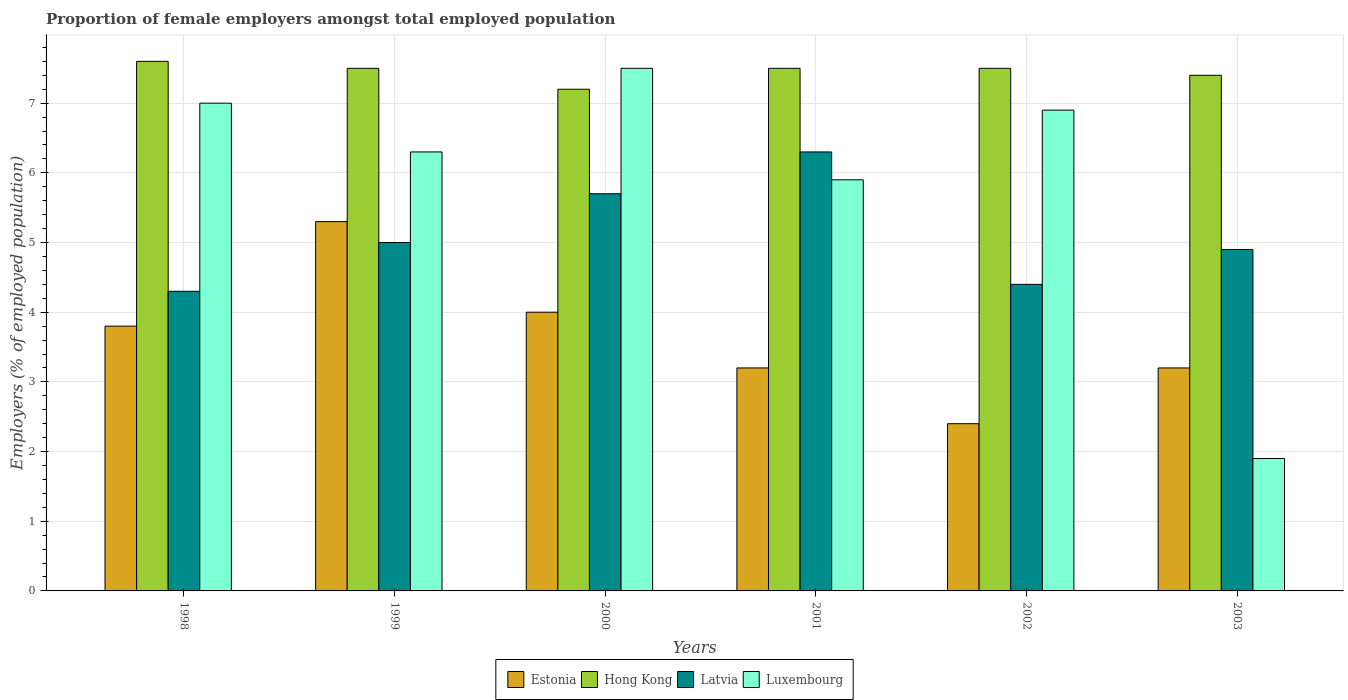How many different coloured bars are there?
Your response must be concise. 4. How many groups of bars are there?
Ensure brevity in your answer.  6. Are the number of bars per tick equal to the number of legend labels?
Offer a terse response. Yes. Are the number of bars on each tick of the X-axis equal?
Your answer should be very brief. Yes. How many bars are there on the 2nd tick from the left?
Give a very brief answer. 4. What is the label of the 1st group of bars from the left?
Your answer should be very brief. 1998. In how many cases, is the number of bars for a given year not equal to the number of legend labels?
Your answer should be very brief. 0. Across all years, what is the maximum proportion of female employers in Latvia?
Ensure brevity in your answer.  6.3. Across all years, what is the minimum proportion of female employers in Estonia?
Ensure brevity in your answer.  2.4. In which year was the proportion of female employers in Hong Kong minimum?
Give a very brief answer. 2000. What is the total proportion of female employers in Luxembourg in the graph?
Provide a succinct answer. 35.5. What is the difference between the proportion of female employers in Hong Kong in 2000 and that in 2001?
Offer a very short reply. -0.3. What is the difference between the proportion of female employers in Hong Kong in 2000 and the proportion of female employers in Estonia in 2003?
Give a very brief answer. 4. What is the average proportion of female employers in Latvia per year?
Provide a succinct answer. 5.1. In how many years, is the proportion of female employers in Luxembourg greater than 6 %?
Provide a succinct answer. 4. What is the ratio of the proportion of female employers in Estonia in 1998 to that in 2002?
Make the answer very short. 1.58. What is the difference between the highest and the second highest proportion of female employers in Latvia?
Provide a short and direct response. 0.6. What is the difference between the highest and the lowest proportion of female employers in Luxembourg?
Provide a succinct answer. 5.6. In how many years, is the proportion of female employers in Estonia greater than the average proportion of female employers in Estonia taken over all years?
Offer a terse response. 3. What does the 1st bar from the left in 2003 represents?
Your answer should be very brief. Estonia. What does the 1st bar from the right in 2003 represents?
Offer a very short reply. Luxembourg. Is it the case that in every year, the sum of the proportion of female employers in Latvia and proportion of female employers in Luxembourg is greater than the proportion of female employers in Estonia?
Provide a succinct answer. Yes. Are all the bars in the graph horizontal?
Your answer should be compact. No. How many years are there in the graph?
Your response must be concise. 6. What is the difference between two consecutive major ticks on the Y-axis?
Keep it short and to the point. 1. Does the graph contain grids?
Your response must be concise. Yes. Where does the legend appear in the graph?
Your answer should be very brief. Bottom center. How many legend labels are there?
Offer a very short reply. 4. How are the legend labels stacked?
Your answer should be very brief. Horizontal. What is the title of the graph?
Ensure brevity in your answer.  Proportion of female employers amongst total employed population. Does "Equatorial Guinea" appear as one of the legend labels in the graph?
Ensure brevity in your answer.  No. What is the label or title of the X-axis?
Your answer should be compact. Years. What is the label or title of the Y-axis?
Provide a succinct answer. Employers (% of employed population). What is the Employers (% of employed population) of Estonia in 1998?
Your response must be concise. 3.8. What is the Employers (% of employed population) in Hong Kong in 1998?
Your answer should be compact. 7.6. What is the Employers (% of employed population) of Latvia in 1998?
Ensure brevity in your answer.  4.3. What is the Employers (% of employed population) of Estonia in 1999?
Your answer should be compact. 5.3. What is the Employers (% of employed population) of Hong Kong in 1999?
Offer a terse response. 7.5. What is the Employers (% of employed population) of Luxembourg in 1999?
Your answer should be very brief. 6.3. What is the Employers (% of employed population) of Hong Kong in 2000?
Provide a succinct answer. 7.2. What is the Employers (% of employed population) in Latvia in 2000?
Your response must be concise. 5.7. What is the Employers (% of employed population) in Luxembourg in 2000?
Offer a terse response. 7.5. What is the Employers (% of employed population) of Estonia in 2001?
Ensure brevity in your answer.  3.2. What is the Employers (% of employed population) of Latvia in 2001?
Offer a terse response. 6.3. What is the Employers (% of employed population) in Luxembourg in 2001?
Your answer should be very brief. 5.9. What is the Employers (% of employed population) of Estonia in 2002?
Your answer should be compact. 2.4. What is the Employers (% of employed population) in Hong Kong in 2002?
Make the answer very short. 7.5. What is the Employers (% of employed population) of Latvia in 2002?
Your answer should be very brief. 4.4. What is the Employers (% of employed population) in Luxembourg in 2002?
Make the answer very short. 6.9. What is the Employers (% of employed population) in Estonia in 2003?
Ensure brevity in your answer.  3.2. What is the Employers (% of employed population) in Hong Kong in 2003?
Keep it short and to the point. 7.4. What is the Employers (% of employed population) in Latvia in 2003?
Your response must be concise. 4.9. What is the Employers (% of employed population) in Luxembourg in 2003?
Give a very brief answer. 1.9. Across all years, what is the maximum Employers (% of employed population) of Estonia?
Provide a short and direct response. 5.3. Across all years, what is the maximum Employers (% of employed population) in Hong Kong?
Provide a succinct answer. 7.6. Across all years, what is the maximum Employers (% of employed population) of Latvia?
Provide a short and direct response. 6.3. Across all years, what is the minimum Employers (% of employed population) of Estonia?
Your response must be concise. 2.4. Across all years, what is the minimum Employers (% of employed population) in Hong Kong?
Make the answer very short. 7.2. Across all years, what is the minimum Employers (% of employed population) in Latvia?
Offer a terse response. 4.3. Across all years, what is the minimum Employers (% of employed population) of Luxembourg?
Provide a succinct answer. 1.9. What is the total Employers (% of employed population) in Estonia in the graph?
Provide a short and direct response. 21.9. What is the total Employers (% of employed population) of Hong Kong in the graph?
Provide a succinct answer. 44.7. What is the total Employers (% of employed population) in Latvia in the graph?
Ensure brevity in your answer.  30.6. What is the total Employers (% of employed population) of Luxembourg in the graph?
Make the answer very short. 35.5. What is the difference between the Employers (% of employed population) of Hong Kong in 1998 and that in 1999?
Offer a very short reply. 0.1. What is the difference between the Employers (% of employed population) in Latvia in 1998 and that in 1999?
Your answer should be very brief. -0.7. What is the difference between the Employers (% of employed population) in Luxembourg in 1998 and that in 1999?
Ensure brevity in your answer.  0.7. What is the difference between the Employers (% of employed population) of Estonia in 1998 and that in 2000?
Provide a succinct answer. -0.2. What is the difference between the Employers (% of employed population) in Hong Kong in 1998 and that in 2000?
Provide a succinct answer. 0.4. What is the difference between the Employers (% of employed population) of Luxembourg in 1998 and that in 2000?
Provide a succinct answer. -0.5. What is the difference between the Employers (% of employed population) of Hong Kong in 1998 and that in 2001?
Offer a terse response. 0.1. What is the difference between the Employers (% of employed population) in Latvia in 1998 and that in 2001?
Provide a succinct answer. -2. What is the difference between the Employers (% of employed population) in Luxembourg in 1998 and that in 2001?
Give a very brief answer. 1.1. What is the difference between the Employers (% of employed population) of Hong Kong in 1998 and that in 2003?
Provide a short and direct response. 0.2. What is the difference between the Employers (% of employed population) in Latvia in 1998 and that in 2003?
Provide a short and direct response. -0.6. What is the difference between the Employers (% of employed population) in Luxembourg in 1998 and that in 2003?
Ensure brevity in your answer.  5.1. What is the difference between the Employers (% of employed population) of Latvia in 1999 and that in 2000?
Ensure brevity in your answer.  -0.7. What is the difference between the Employers (% of employed population) in Luxembourg in 1999 and that in 2000?
Ensure brevity in your answer.  -1.2. What is the difference between the Employers (% of employed population) of Estonia in 1999 and that in 2001?
Provide a succinct answer. 2.1. What is the difference between the Employers (% of employed population) in Latvia in 1999 and that in 2001?
Offer a terse response. -1.3. What is the difference between the Employers (% of employed population) in Latvia in 1999 and that in 2002?
Keep it short and to the point. 0.6. What is the difference between the Employers (% of employed population) in Hong Kong in 1999 and that in 2003?
Offer a terse response. 0.1. What is the difference between the Employers (% of employed population) of Luxembourg in 1999 and that in 2003?
Your response must be concise. 4.4. What is the difference between the Employers (% of employed population) of Estonia in 2000 and that in 2001?
Provide a succinct answer. 0.8. What is the difference between the Employers (% of employed population) of Hong Kong in 2000 and that in 2001?
Your response must be concise. -0.3. What is the difference between the Employers (% of employed population) of Luxembourg in 2000 and that in 2001?
Ensure brevity in your answer.  1.6. What is the difference between the Employers (% of employed population) in Estonia in 2000 and that in 2002?
Offer a very short reply. 1.6. What is the difference between the Employers (% of employed population) of Hong Kong in 2000 and that in 2002?
Offer a very short reply. -0.3. What is the difference between the Employers (% of employed population) in Luxembourg in 2000 and that in 2002?
Ensure brevity in your answer.  0.6. What is the difference between the Employers (% of employed population) in Estonia in 2000 and that in 2003?
Provide a succinct answer. 0.8. What is the difference between the Employers (% of employed population) in Luxembourg in 2000 and that in 2003?
Your answer should be very brief. 5.6. What is the difference between the Employers (% of employed population) of Hong Kong in 2001 and that in 2002?
Keep it short and to the point. 0. What is the difference between the Employers (% of employed population) in Estonia in 2001 and that in 2003?
Offer a very short reply. 0. What is the difference between the Employers (% of employed population) in Hong Kong in 2001 and that in 2003?
Your answer should be very brief. 0.1. What is the difference between the Employers (% of employed population) in Latvia in 2001 and that in 2003?
Ensure brevity in your answer.  1.4. What is the difference between the Employers (% of employed population) of Estonia in 2002 and that in 2003?
Keep it short and to the point. -0.8. What is the difference between the Employers (% of employed population) of Hong Kong in 2002 and that in 2003?
Your answer should be compact. 0.1. What is the difference between the Employers (% of employed population) in Estonia in 1998 and the Employers (% of employed population) in Luxembourg in 1999?
Offer a terse response. -2.5. What is the difference between the Employers (% of employed population) in Hong Kong in 1998 and the Employers (% of employed population) in Latvia in 1999?
Provide a short and direct response. 2.6. What is the difference between the Employers (% of employed population) of Estonia in 1998 and the Employers (% of employed population) of Hong Kong in 2000?
Keep it short and to the point. -3.4. What is the difference between the Employers (% of employed population) of Latvia in 1998 and the Employers (% of employed population) of Luxembourg in 2000?
Make the answer very short. -3.2. What is the difference between the Employers (% of employed population) in Hong Kong in 1998 and the Employers (% of employed population) in Latvia in 2001?
Your answer should be very brief. 1.3. What is the difference between the Employers (% of employed population) in Hong Kong in 1998 and the Employers (% of employed population) in Luxembourg in 2001?
Provide a succinct answer. 1.7. What is the difference between the Employers (% of employed population) of Latvia in 1998 and the Employers (% of employed population) of Luxembourg in 2001?
Keep it short and to the point. -1.6. What is the difference between the Employers (% of employed population) in Estonia in 1998 and the Employers (% of employed population) in Latvia in 2002?
Keep it short and to the point. -0.6. What is the difference between the Employers (% of employed population) of Hong Kong in 1998 and the Employers (% of employed population) of Latvia in 2002?
Your response must be concise. 3.2. What is the difference between the Employers (% of employed population) in Hong Kong in 1998 and the Employers (% of employed population) in Luxembourg in 2002?
Your answer should be very brief. 0.7. What is the difference between the Employers (% of employed population) of Latvia in 1998 and the Employers (% of employed population) of Luxembourg in 2002?
Provide a succinct answer. -2.6. What is the difference between the Employers (% of employed population) of Estonia in 1998 and the Employers (% of employed population) of Hong Kong in 2003?
Ensure brevity in your answer.  -3.6. What is the difference between the Employers (% of employed population) in Estonia in 1998 and the Employers (% of employed population) in Latvia in 2003?
Provide a short and direct response. -1.1. What is the difference between the Employers (% of employed population) of Hong Kong in 1998 and the Employers (% of employed population) of Luxembourg in 2003?
Provide a short and direct response. 5.7. What is the difference between the Employers (% of employed population) of Latvia in 1998 and the Employers (% of employed population) of Luxembourg in 2003?
Provide a short and direct response. 2.4. What is the difference between the Employers (% of employed population) in Estonia in 1999 and the Employers (% of employed population) in Hong Kong in 2000?
Offer a very short reply. -1.9. What is the difference between the Employers (% of employed population) of Estonia in 1999 and the Employers (% of employed population) of Luxembourg in 2000?
Provide a succinct answer. -2.2. What is the difference between the Employers (% of employed population) in Hong Kong in 1999 and the Employers (% of employed population) in Latvia in 2000?
Your response must be concise. 1.8. What is the difference between the Employers (% of employed population) of Estonia in 1999 and the Employers (% of employed population) of Latvia in 2001?
Offer a terse response. -1. What is the difference between the Employers (% of employed population) of Estonia in 1999 and the Employers (% of employed population) of Luxembourg in 2001?
Your response must be concise. -0.6. What is the difference between the Employers (% of employed population) in Hong Kong in 1999 and the Employers (% of employed population) in Latvia in 2001?
Your response must be concise. 1.2. What is the difference between the Employers (% of employed population) of Hong Kong in 1999 and the Employers (% of employed population) of Luxembourg in 2001?
Your answer should be compact. 1.6. What is the difference between the Employers (% of employed population) in Estonia in 1999 and the Employers (% of employed population) in Hong Kong in 2002?
Provide a succinct answer. -2.2. What is the difference between the Employers (% of employed population) in Estonia in 1999 and the Employers (% of employed population) in Latvia in 2002?
Give a very brief answer. 0.9. What is the difference between the Employers (% of employed population) in Estonia in 1999 and the Employers (% of employed population) in Luxembourg in 2002?
Offer a terse response. -1.6. What is the difference between the Employers (% of employed population) of Hong Kong in 1999 and the Employers (% of employed population) of Luxembourg in 2002?
Make the answer very short. 0.6. What is the difference between the Employers (% of employed population) of Estonia in 1999 and the Employers (% of employed population) of Hong Kong in 2003?
Keep it short and to the point. -2.1. What is the difference between the Employers (% of employed population) of Estonia in 1999 and the Employers (% of employed population) of Latvia in 2003?
Offer a very short reply. 0.4. What is the difference between the Employers (% of employed population) of Hong Kong in 1999 and the Employers (% of employed population) of Latvia in 2003?
Offer a very short reply. 2.6. What is the difference between the Employers (% of employed population) in Hong Kong in 1999 and the Employers (% of employed population) in Luxembourg in 2003?
Provide a short and direct response. 5.6. What is the difference between the Employers (% of employed population) in Estonia in 2000 and the Employers (% of employed population) in Hong Kong in 2001?
Provide a succinct answer. -3.5. What is the difference between the Employers (% of employed population) of Estonia in 2000 and the Employers (% of employed population) of Latvia in 2001?
Keep it short and to the point. -2.3. What is the difference between the Employers (% of employed population) in Estonia in 2000 and the Employers (% of employed population) in Latvia in 2002?
Your answer should be compact. -0.4. What is the difference between the Employers (% of employed population) of Estonia in 2000 and the Employers (% of employed population) of Luxembourg in 2002?
Offer a terse response. -2.9. What is the difference between the Employers (% of employed population) of Hong Kong in 2000 and the Employers (% of employed population) of Latvia in 2002?
Your answer should be very brief. 2.8. What is the difference between the Employers (% of employed population) of Hong Kong in 2000 and the Employers (% of employed population) of Luxembourg in 2002?
Provide a short and direct response. 0.3. What is the difference between the Employers (% of employed population) in Hong Kong in 2000 and the Employers (% of employed population) in Luxembourg in 2003?
Give a very brief answer. 5.3. What is the difference between the Employers (% of employed population) in Estonia in 2001 and the Employers (% of employed population) in Luxembourg in 2002?
Offer a very short reply. -3.7. What is the difference between the Employers (% of employed population) of Hong Kong in 2001 and the Employers (% of employed population) of Latvia in 2002?
Give a very brief answer. 3.1. What is the difference between the Employers (% of employed population) of Latvia in 2001 and the Employers (% of employed population) of Luxembourg in 2002?
Give a very brief answer. -0.6. What is the difference between the Employers (% of employed population) of Estonia in 2001 and the Employers (% of employed population) of Luxembourg in 2003?
Your answer should be very brief. 1.3. What is the difference between the Employers (% of employed population) of Hong Kong in 2001 and the Employers (% of employed population) of Latvia in 2003?
Give a very brief answer. 2.6. What is the difference between the Employers (% of employed population) in Hong Kong in 2001 and the Employers (% of employed population) in Luxembourg in 2003?
Your answer should be compact. 5.6. What is the difference between the Employers (% of employed population) of Latvia in 2001 and the Employers (% of employed population) of Luxembourg in 2003?
Your answer should be very brief. 4.4. What is the difference between the Employers (% of employed population) in Estonia in 2002 and the Employers (% of employed population) in Hong Kong in 2003?
Offer a terse response. -5. What is the average Employers (% of employed population) in Estonia per year?
Provide a short and direct response. 3.65. What is the average Employers (% of employed population) in Hong Kong per year?
Offer a terse response. 7.45. What is the average Employers (% of employed population) of Latvia per year?
Offer a terse response. 5.1. What is the average Employers (% of employed population) in Luxembourg per year?
Provide a succinct answer. 5.92. In the year 1998, what is the difference between the Employers (% of employed population) of Estonia and Employers (% of employed population) of Hong Kong?
Your answer should be compact. -3.8. In the year 1998, what is the difference between the Employers (% of employed population) in Estonia and Employers (% of employed population) in Latvia?
Offer a very short reply. -0.5. In the year 1998, what is the difference between the Employers (% of employed population) of Latvia and Employers (% of employed population) of Luxembourg?
Your response must be concise. -2.7. In the year 1999, what is the difference between the Employers (% of employed population) in Hong Kong and Employers (% of employed population) in Latvia?
Your response must be concise. 2.5. In the year 1999, what is the difference between the Employers (% of employed population) of Hong Kong and Employers (% of employed population) of Luxembourg?
Your response must be concise. 1.2. In the year 1999, what is the difference between the Employers (% of employed population) in Latvia and Employers (% of employed population) in Luxembourg?
Provide a succinct answer. -1.3. In the year 2000, what is the difference between the Employers (% of employed population) of Estonia and Employers (% of employed population) of Hong Kong?
Your answer should be compact. -3.2. In the year 2000, what is the difference between the Employers (% of employed population) of Estonia and Employers (% of employed population) of Latvia?
Your answer should be compact. -1.7. In the year 2000, what is the difference between the Employers (% of employed population) of Hong Kong and Employers (% of employed population) of Latvia?
Keep it short and to the point. 1.5. In the year 2000, what is the difference between the Employers (% of employed population) in Hong Kong and Employers (% of employed population) in Luxembourg?
Offer a terse response. -0.3. In the year 2000, what is the difference between the Employers (% of employed population) in Latvia and Employers (% of employed population) in Luxembourg?
Give a very brief answer. -1.8. In the year 2001, what is the difference between the Employers (% of employed population) in Estonia and Employers (% of employed population) in Hong Kong?
Ensure brevity in your answer.  -4.3. In the year 2001, what is the difference between the Employers (% of employed population) of Estonia and Employers (% of employed population) of Latvia?
Provide a succinct answer. -3.1. In the year 2001, what is the difference between the Employers (% of employed population) in Estonia and Employers (% of employed population) in Luxembourg?
Your answer should be very brief. -2.7. In the year 2001, what is the difference between the Employers (% of employed population) of Latvia and Employers (% of employed population) of Luxembourg?
Offer a very short reply. 0.4. In the year 2002, what is the difference between the Employers (% of employed population) in Estonia and Employers (% of employed population) in Hong Kong?
Make the answer very short. -5.1. In the year 2002, what is the difference between the Employers (% of employed population) of Estonia and Employers (% of employed population) of Luxembourg?
Provide a short and direct response. -4.5. In the year 2002, what is the difference between the Employers (% of employed population) of Hong Kong and Employers (% of employed population) of Latvia?
Your answer should be compact. 3.1. In the year 2002, what is the difference between the Employers (% of employed population) in Hong Kong and Employers (% of employed population) in Luxembourg?
Your answer should be compact. 0.6. In the year 2002, what is the difference between the Employers (% of employed population) in Latvia and Employers (% of employed population) in Luxembourg?
Provide a short and direct response. -2.5. In the year 2003, what is the difference between the Employers (% of employed population) of Estonia and Employers (% of employed population) of Latvia?
Your answer should be compact. -1.7. In the year 2003, what is the difference between the Employers (% of employed population) of Estonia and Employers (% of employed population) of Luxembourg?
Offer a terse response. 1.3. In the year 2003, what is the difference between the Employers (% of employed population) in Hong Kong and Employers (% of employed population) in Latvia?
Ensure brevity in your answer.  2.5. What is the ratio of the Employers (% of employed population) of Estonia in 1998 to that in 1999?
Make the answer very short. 0.72. What is the ratio of the Employers (% of employed population) of Hong Kong in 1998 to that in 1999?
Provide a short and direct response. 1.01. What is the ratio of the Employers (% of employed population) of Latvia in 1998 to that in 1999?
Offer a terse response. 0.86. What is the ratio of the Employers (% of employed population) of Luxembourg in 1998 to that in 1999?
Your response must be concise. 1.11. What is the ratio of the Employers (% of employed population) in Estonia in 1998 to that in 2000?
Give a very brief answer. 0.95. What is the ratio of the Employers (% of employed population) of Hong Kong in 1998 to that in 2000?
Provide a succinct answer. 1.06. What is the ratio of the Employers (% of employed population) of Latvia in 1998 to that in 2000?
Your answer should be compact. 0.75. What is the ratio of the Employers (% of employed population) in Luxembourg in 1998 to that in 2000?
Make the answer very short. 0.93. What is the ratio of the Employers (% of employed population) of Estonia in 1998 to that in 2001?
Provide a succinct answer. 1.19. What is the ratio of the Employers (% of employed population) in Hong Kong in 1998 to that in 2001?
Provide a short and direct response. 1.01. What is the ratio of the Employers (% of employed population) in Latvia in 1998 to that in 2001?
Keep it short and to the point. 0.68. What is the ratio of the Employers (% of employed population) in Luxembourg in 1998 to that in 2001?
Your response must be concise. 1.19. What is the ratio of the Employers (% of employed population) of Estonia in 1998 to that in 2002?
Your response must be concise. 1.58. What is the ratio of the Employers (% of employed population) in Hong Kong in 1998 to that in 2002?
Make the answer very short. 1.01. What is the ratio of the Employers (% of employed population) of Latvia in 1998 to that in 2002?
Keep it short and to the point. 0.98. What is the ratio of the Employers (% of employed population) of Luxembourg in 1998 to that in 2002?
Make the answer very short. 1.01. What is the ratio of the Employers (% of employed population) in Estonia in 1998 to that in 2003?
Offer a very short reply. 1.19. What is the ratio of the Employers (% of employed population) in Hong Kong in 1998 to that in 2003?
Your response must be concise. 1.03. What is the ratio of the Employers (% of employed population) of Latvia in 1998 to that in 2003?
Provide a succinct answer. 0.88. What is the ratio of the Employers (% of employed population) in Luxembourg in 1998 to that in 2003?
Offer a very short reply. 3.68. What is the ratio of the Employers (% of employed population) of Estonia in 1999 to that in 2000?
Provide a succinct answer. 1.32. What is the ratio of the Employers (% of employed population) of Hong Kong in 1999 to that in 2000?
Make the answer very short. 1.04. What is the ratio of the Employers (% of employed population) in Latvia in 1999 to that in 2000?
Your response must be concise. 0.88. What is the ratio of the Employers (% of employed population) in Luxembourg in 1999 to that in 2000?
Keep it short and to the point. 0.84. What is the ratio of the Employers (% of employed population) of Estonia in 1999 to that in 2001?
Your response must be concise. 1.66. What is the ratio of the Employers (% of employed population) in Hong Kong in 1999 to that in 2001?
Your answer should be compact. 1. What is the ratio of the Employers (% of employed population) in Latvia in 1999 to that in 2001?
Offer a very short reply. 0.79. What is the ratio of the Employers (% of employed population) in Luxembourg in 1999 to that in 2001?
Your answer should be compact. 1.07. What is the ratio of the Employers (% of employed population) in Estonia in 1999 to that in 2002?
Ensure brevity in your answer.  2.21. What is the ratio of the Employers (% of employed population) of Hong Kong in 1999 to that in 2002?
Keep it short and to the point. 1. What is the ratio of the Employers (% of employed population) of Latvia in 1999 to that in 2002?
Make the answer very short. 1.14. What is the ratio of the Employers (% of employed population) of Luxembourg in 1999 to that in 2002?
Your answer should be very brief. 0.91. What is the ratio of the Employers (% of employed population) of Estonia in 1999 to that in 2003?
Keep it short and to the point. 1.66. What is the ratio of the Employers (% of employed population) of Hong Kong in 1999 to that in 2003?
Your answer should be compact. 1.01. What is the ratio of the Employers (% of employed population) of Latvia in 1999 to that in 2003?
Provide a succinct answer. 1.02. What is the ratio of the Employers (% of employed population) of Luxembourg in 1999 to that in 2003?
Give a very brief answer. 3.32. What is the ratio of the Employers (% of employed population) in Estonia in 2000 to that in 2001?
Offer a very short reply. 1.25. What is the ratio of the Employers (% of employed population) of Latvia in 2000 to that in 2001?
Your response must be concise. 0.9. What is the ratio of the Employers (% of employed population) in Luxembourg in 2000 to that in 2001?
Your answer should be compact. 1.27. What is the ratio of the Employers (% of employed population) of Estonia in 2000 to that in 2002?
Provide a succinct answer. 1.67. What is the ratio of the Employers (% of employed population) of Latvia in 2000 to that in 2002?
Your answer should be compact. 1.3. What is the ratio of the Employers (% of employed population) of Luxembourg in 2000 to that in 2002?
Your response must be concise. 1.09. What is the ratio of the Employers (% of employed population) in Estonia in 2000 to that in 2003?
Provide a succinct answer. 1.25. What is the ratio of the Employers (% of employed population) of Hong Kong in 2000 to that in 2003?
Provide a succinct answer. 0.97. What is the ratio of the Employers (% of employed population) of Latvia in 2000 to that in 2003?
Offer a terse response. 1.16. What is the ratio of the Employers (% of employed population) in Luxembourg in 2000 to that in 2003?
Your answer should be compact. 3.95. What is the ratio of the Employers (% of employed population) in Hong Kong in 2001 to that in 2002?
Your response must be concise. 1. What is the ratio of the Employers (% of employed population) in Latvia in 2001 to that in 2002?
Make the answer very short. 1.43. What is the ratio of the Employers (% of employed population) in Luxembourg in 2001 to that in 2002?
Ensure brevity in your answer.  0.86. What is the ratio of the Employers (% of employed population) of Estonia in 2001 to that in 2003?
Your response must be concise. 1. What is the ratio of the Employers (% of employed population) in Hong Kong in 2001 to that in 2003?
Keep it short and to the point. 1.01. What is the ratio of the Employers (% of employed population) in Luxembourg in 2001 to that in 2003?
Make the answer very short. 3.11. What is the ratio of the Employers (% of employed population) in Estonia in 2002 to that in 2003?
Offer a terse response. 0.75. What is the ratio of the Employers (% of employed population) of Hong Kong in 2002 to that in 2003?
Provide a short and direct response. 1.01. What is the ratio of the Employers (% of employed population) in Latvia in 2002 to that in 2003?
Your response must be concise. 0.9. What is the ratio of the Employers (% of employed population) in Luxembourg in 2002 to that in 2003?
Your response must be concise. 3.63. What is the difference between the highest and the second highest Employers (% of employed population) of Estonia?
Ensure brevity in your answer.  1.3. What is the difference between the highest and the second highest Employers (% of employed population) in Latvia?
Offer a terse response. 0.6. What is the difference between the highest and the lowest Employers (% of employed population) of Estonia?
Make the answer very short. 2.9. What is the difference between the highest and the lowest Employers (% of employed population) in Hong Kong?
Your answer should be very brief. 0.4. What is the difference between the highest and the lowest Employers (% of employed population) of Luxembourg?
Offer a very short reply. 5.6. 